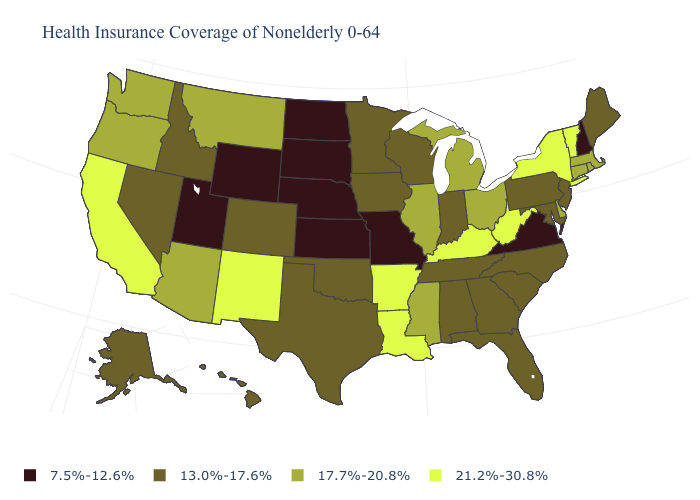What is the value of South Dakota?
Write a very short answer. 7.5%-12.6%. What is the value of Tennessee?
Answer briefly. 13.0%-17.6%. Name the states that have a value in the range 21.2%-30.8%?
Be succinct. Arkansas, California, Kentucky, Louisiana, New Mexico, New York, Vermont, West Virginia. What is the value of Utah?
Answer briefly. 7.5%-12.6%. What is the value of Wisconsin?
Give a very brief answer. 13.0%-17.6%. What is the value of Montana?
Give a very brief answer. 17.7%-20.8%. What is the value of Oklahoma?
Be succinct. 13.0%-17.6%. Among the states that border Kentucky , which have the lowest value?
Be succinct. Missouri, Virginia. Does South Carolina have the highest value in the South?
Answer briefly. No. What is the value of New Hampshire?
Keep it brief. 7.5%-12.6%. Which states have the lowest value in the USA?
Write a very short answer. Kansas, Missouri, Nebraska, New Hampshire, North Dakota, South Dakota, Utah, Virginia, Wyoming. What is the lowest value in states that border Rhode Island?
Give a very brief answer. 17.7%-20.8%. Name the states that have a value in the range 7.5%-12.6%?
Concise answer only. Kansas, Missouri, Nebraska, New Hampshire, North Dakota, South Dakota, Utah, Virginia, Wyoming. What is the value of Oregon?
Keep it brief. 17.7%-20.8%. Does Arkansas have a higher value than New York?
Be succinct. No. 